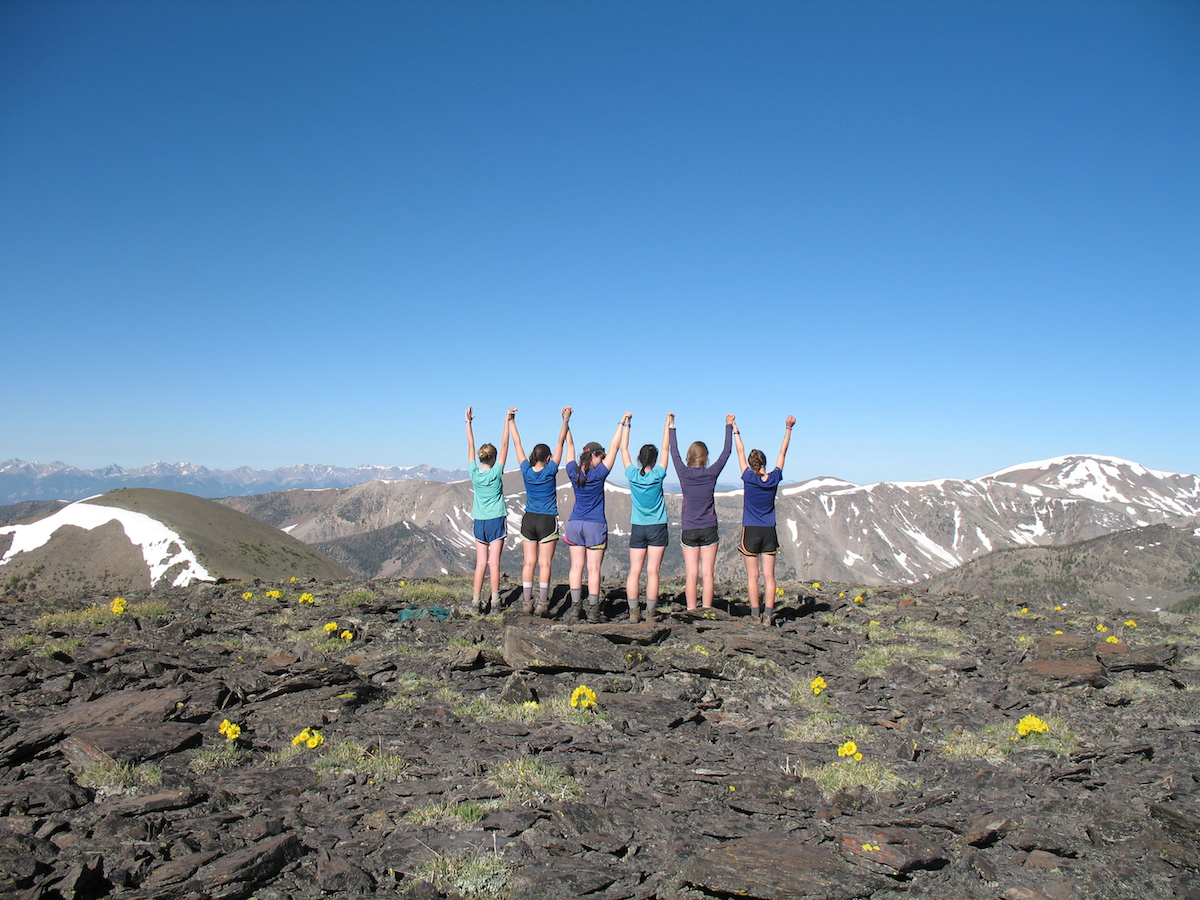Can you describe the type of terrain in the photograph? The terrain in the photograph is rugged and rocky, with sparse vegetation. The ground appears to be covered with a layer of dark volcanic rocks or similar geological material, which suggests a high-altitude or mountainous area. Few patches of bright yellow flowers add a contrast to the otherwise stark landscape, indicative of resilient flora adapting to thin soils and possibly harsh weather conditions. 